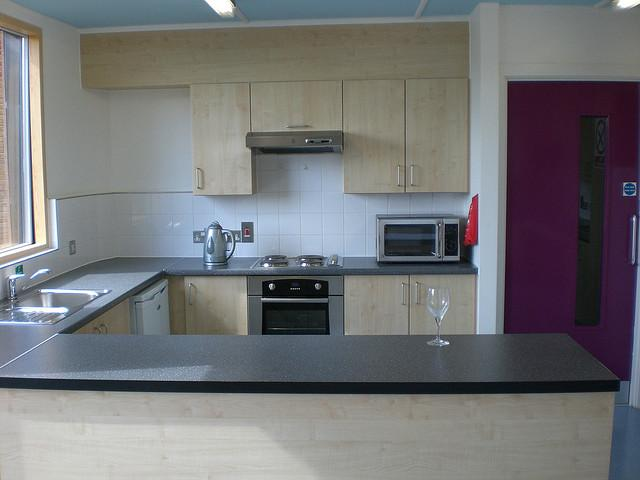What is on top of the counter? wine glass 